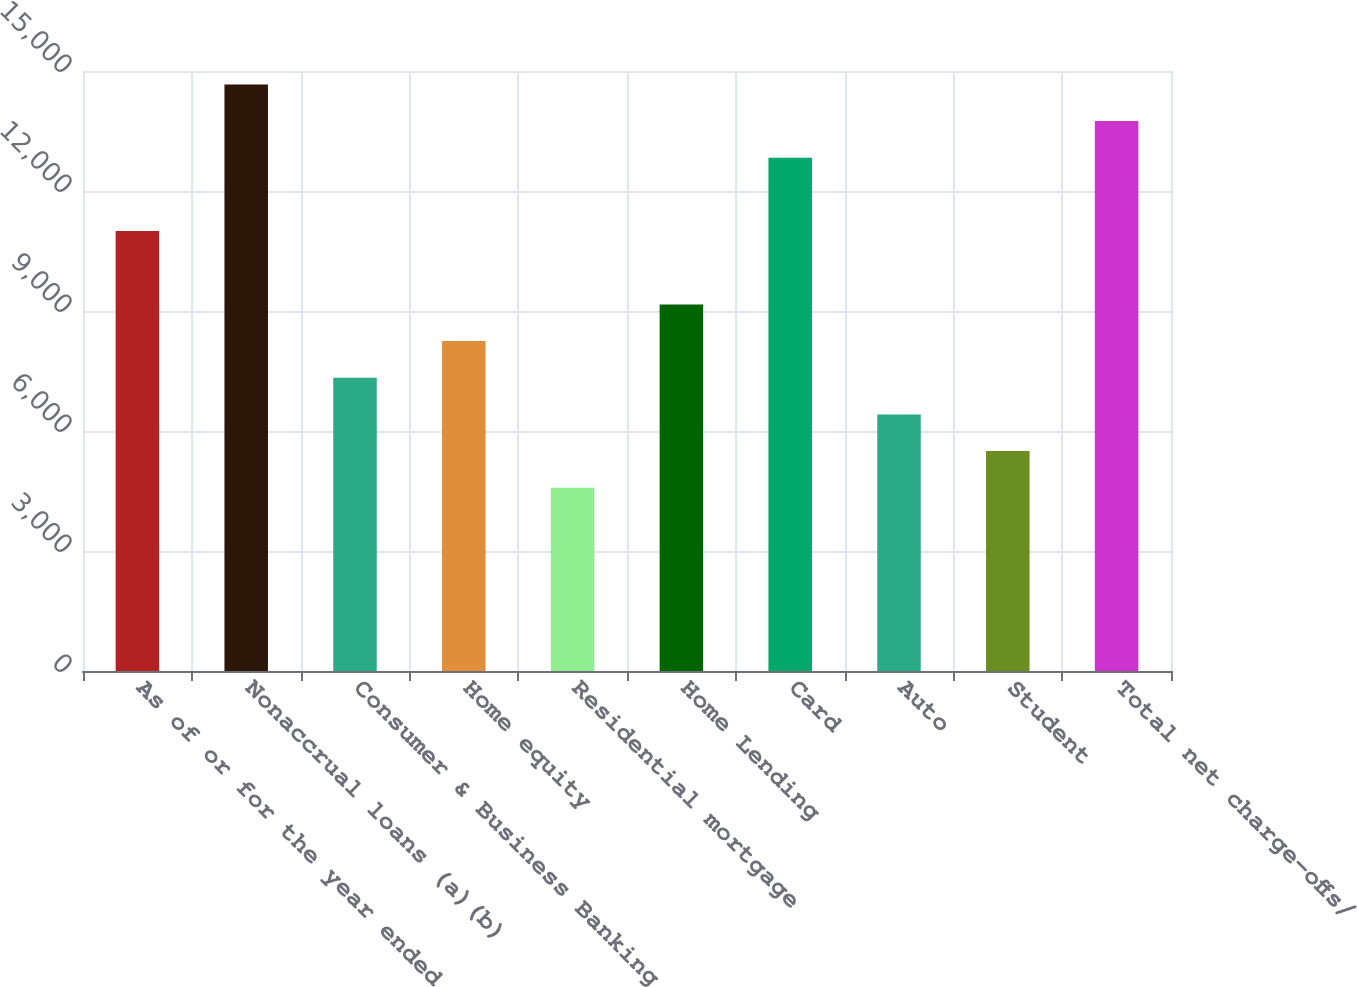<chart> <loc_0><loc_0><loc_500><loc_500><bar_chart><fcel>As of or for the year ended<fcel>Nonaccrual loans (a)(b)<fcel>Consumer & Business Banking<fcel>Home equity<fcel>Residential mortgage<fcel>Home Lending<fcel>Card<fcel>Auto<fcel>Student<fcel>Total net charge-offs/<nl><fcel>10997.9<fcel>14663.9<fcel>7332.02<fcel>8248.5<fcel>4582.58<fcel>9164.98<fcel>12830.9<fcel>6415.54<fcel>5499.06<fcel>13747.4<nl></chart> 